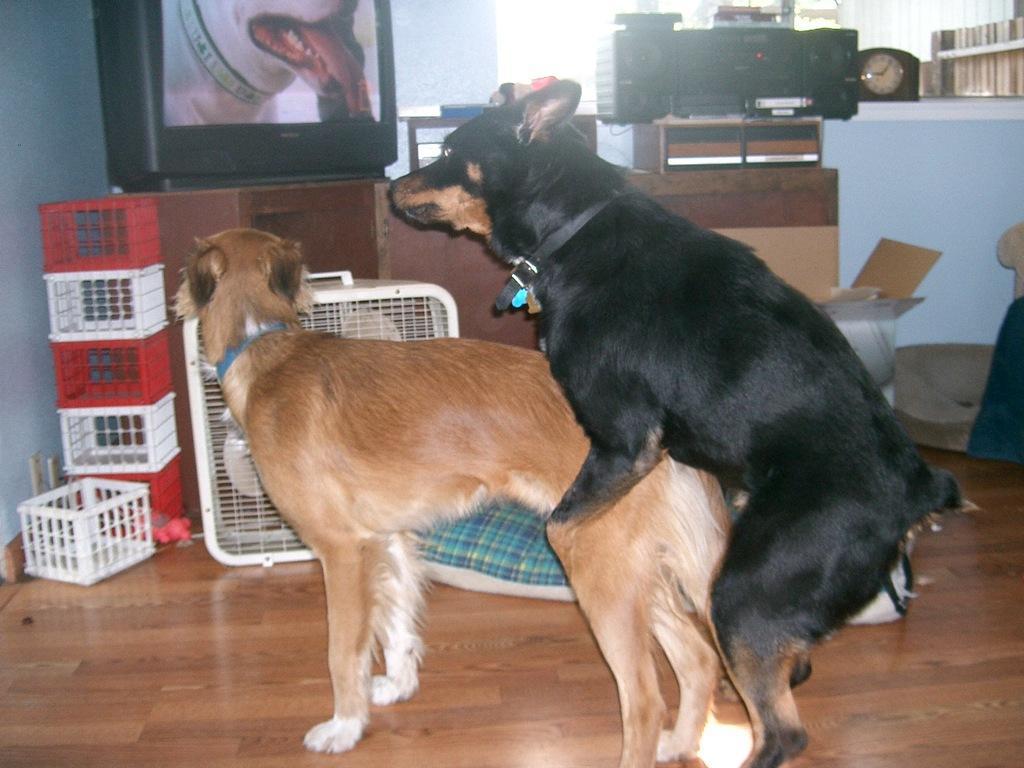Please provide a concise description of this image. In the center of the image we can see the dogs. In the background of the image we can see the containers, rack, screen, machine, clock, boxes, pillow and books. At the bottom of the image we can see the floor. 